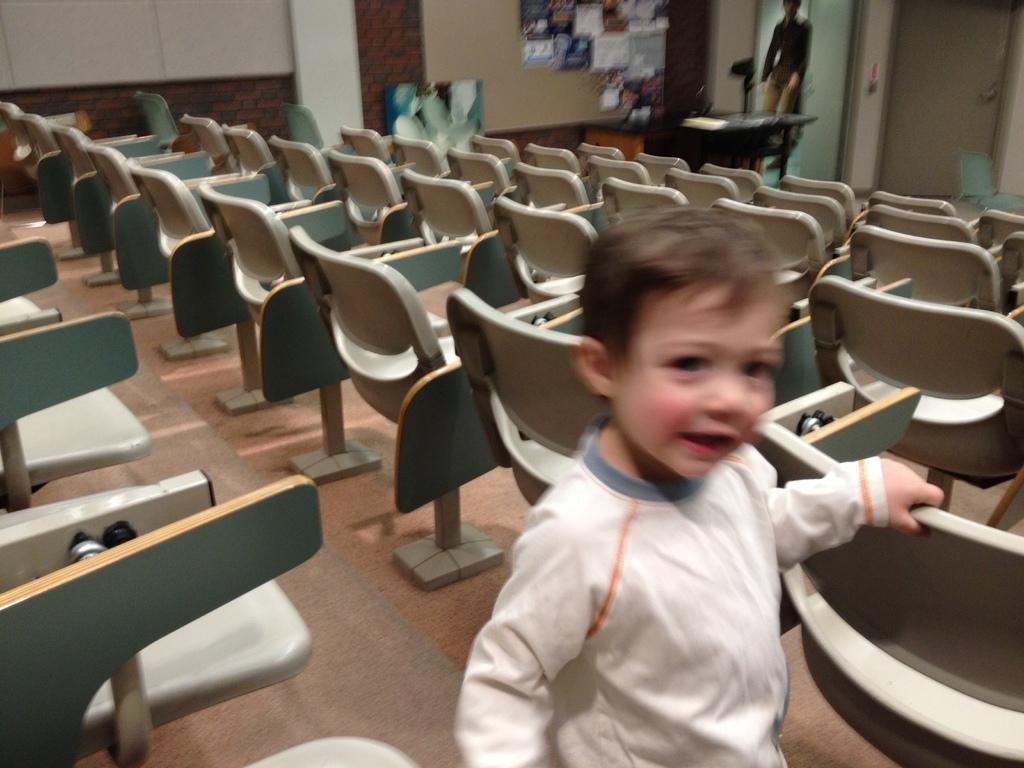What is the boy doing in the image? The boy is standing on the floor in the image. What furniture is present in the image? There are chairs and a table in the image. What can be seen behind the boy and furniture? There is a wall visible in the image. What type of cheese is the boy holding in the image? There is no cheese present in the image; the boy is simply standing on the floor. 